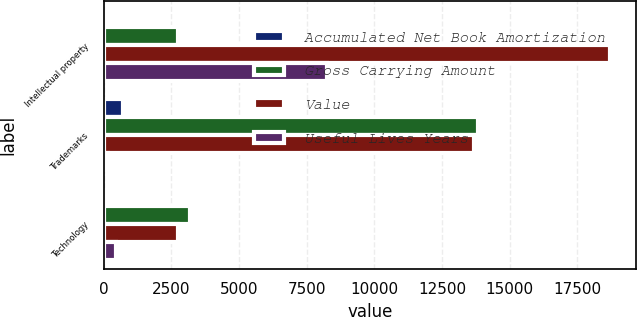<chart> <loc_0><loc_0><loc_500><loc_500><stacked_bar_chart><ecel><fcel>Intellectual property<fcel>Trademarks<fcel>Technology<nl><fcel>Accumulated Net Book Amortization<fcel>26<fcel>710<fcel>3<nl><fcel>Gross Carrying Amount<fcel>2760<fcel>13838<fcel>3200<nl><fcel>Value<fcel>18718<fcel>13682<fcel>2760<nl><fcel>Useful Lives Years<fcel>8231<fcel>156<fcel>440<nl></chart> 